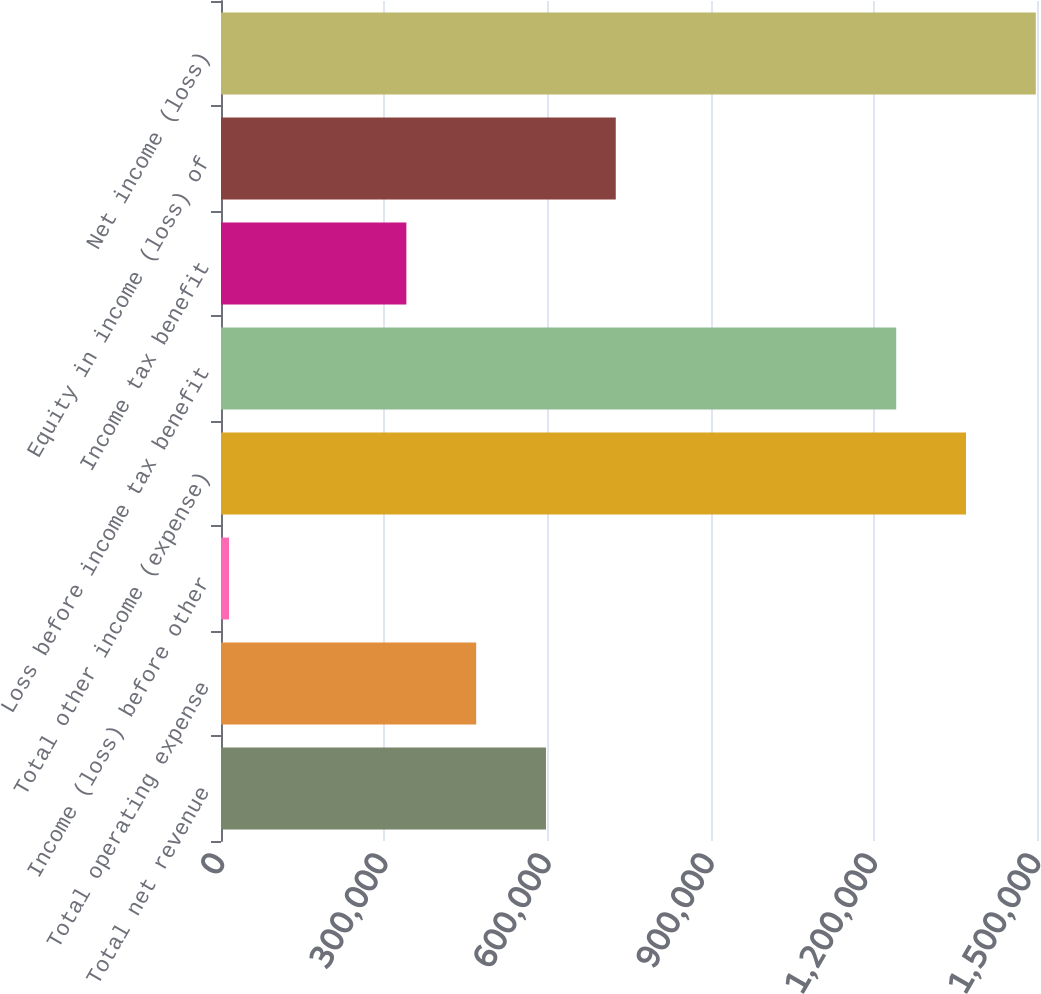Convert chart. <chart><loc_0><loc_0><loc_500><loc_500><bar_chart><fcel>Total net revenue<fcel>Total operating expense<fcel>Income (loss) before other<fcel>Total other income (expense)<fcel>Loss before income tax benefit<fcel>Income tax benefit<fcel>Equity in income (loss) of<fcel>Net income (loss)<nl><fcel>597362<fcel>469055<fcel>14699<fcel>1.36949e+06<fcel>1.24118e+06<fcel>340749<fcel>725668<fcel>1.4978e+06<nl></chart> 